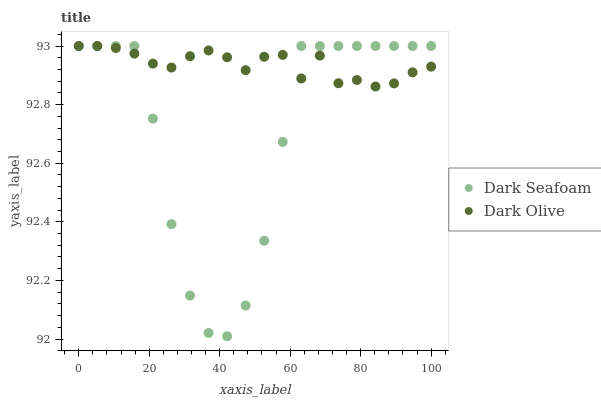Does Dark Seafoam have the minimum area under the curve?
Answer yes or no. Yes. Does Dark Olive have the maximum area under the curve?
Answer yes or no. Yes. Does Dark Olive have the minimum area under the curve?
Answer yes or no. No. Is Dark Olive the smoothest?
Answer yes or no. Yes. Is Dark Seafoam the roughest?
Answer yes or no. Yes. Is Dark Olive the roughest?
Answer yes or no. No. Does Dark Seafoam have the lowest value?
Answer yes or no. Yes. Does Dark Olive have the lowest value?
Answer yes or no. No. Does Dark Olive have the highest value?
Answer yes or no. Yes. Does Dark Seafoam intersect Dark Olive?
Answer yes or no. Yes. Is Dark Seafoam less than Dark Olive?
Answer yes or no. No. Is Dark Seafoam greater than Dark Olive?
Answer yes or no. No. 